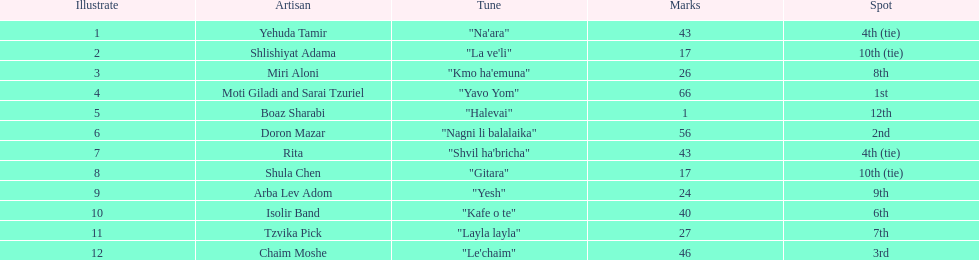What artist received the least amount of points in the competition? Boaz Sharabi. 